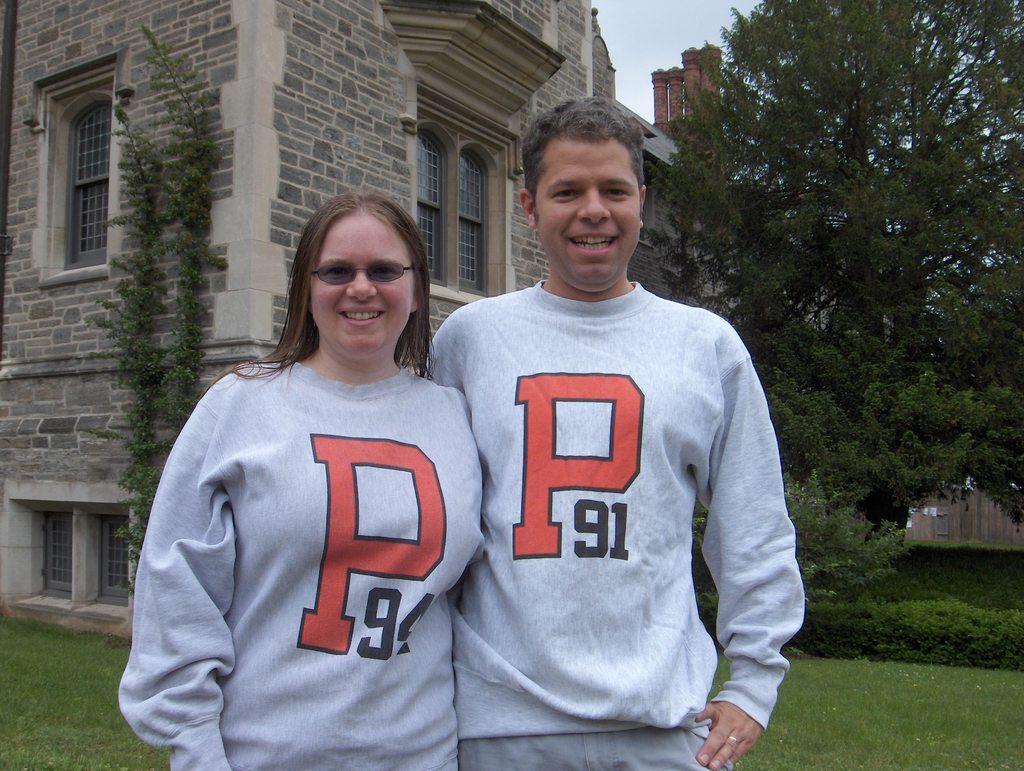What letters are on their sweaters?
Ensure brevity in your answer.  P. What numbers are on the shirts?
Give a very brief answer. 91. 